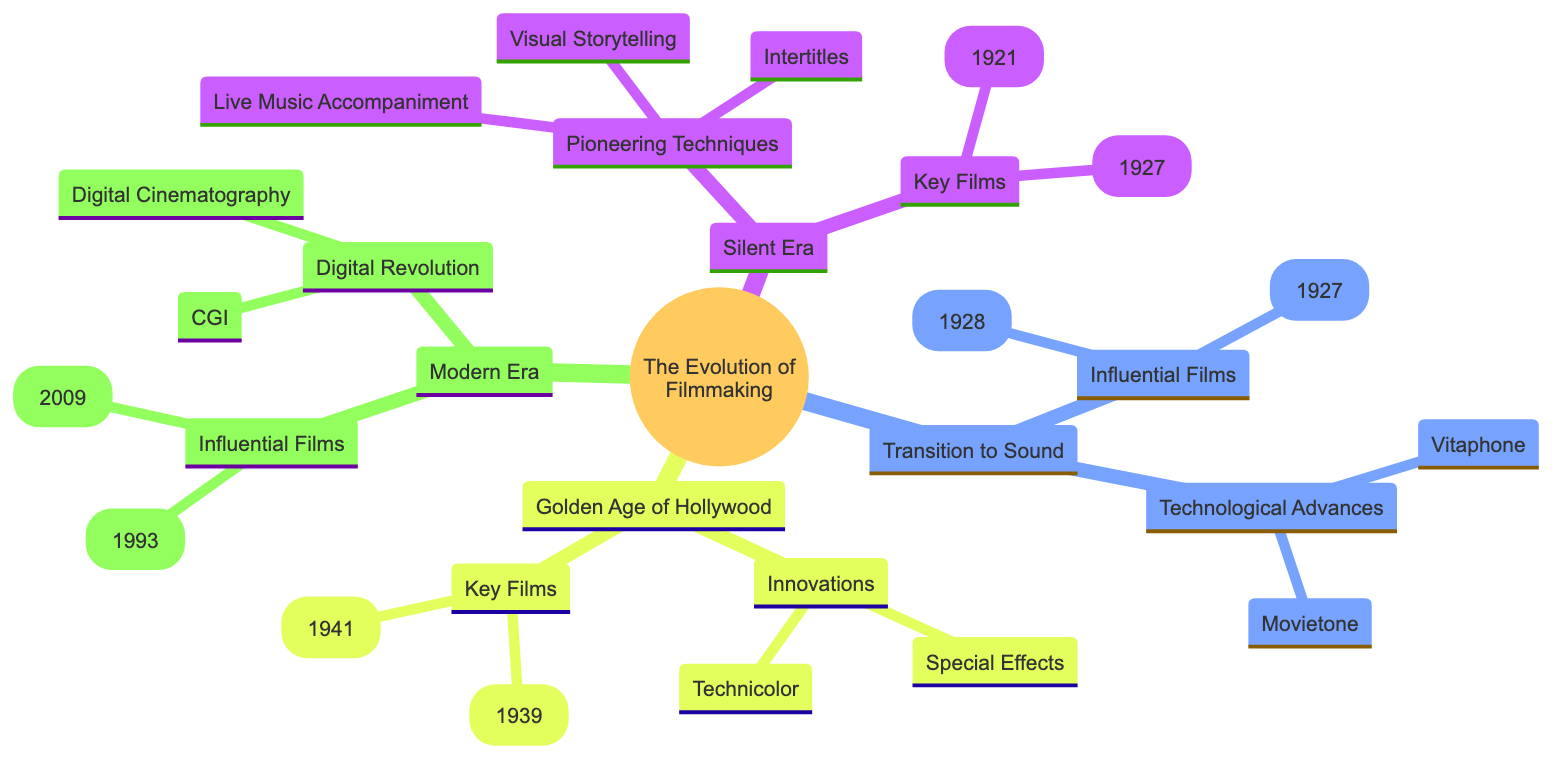What are two pioneering techniques from the Silent Era? According to the diagram, the "Pioneering Techniques" branch under "Silent Era" includes "Intertitles" and "Visual Storytelling". Thus, the two techniques are those listed in this section.
Answer: Intertitles, Visual Storytelling Who directed "Citizen Kane"? The diagram provides a section under "Key Films" in the "Golden Age of Hollywood" where "Citizen Kane" is listed along with its director, which is "Orson Welles".
Answer: Orson Welles What technological advance is associated with the Vitaphone? In the "Transition to Sound" section, it notes that "Vitaphone" is a "Sound-on-disc system", linking the technological advance directly with its description.
Answer: Sound-on-disc system How many key films are listed in the Golden Age of Hollywood? Under "Key Films" within the "Golden Age of Hollywood", there are two specific films listed, which refer to the count of films in that section. Therefore, the answer reflects this quantity.
Answer: 2 What film is recognized for pioneering CGI integration? The "Influential Films" under "Modern Era" states that "Jurassic Park (1993)" is significant for pioneering CGI integration, making it the key example of this evolution.
Answer: Jurassic Park (1993) Which sound system is tied to the concept of sound-on-film? The diagram specifies that "Movietone" falls under "Technological Advances" in the "Transition to Sound" category and is described as a "Sound-on-film system", indicating its association.
Answer: Sound-on-film system What was a distinctive feature of the special effects during the Golden Age of Hollywood? "Special Effects" under "Innovations" in the "Golden Age of Hollywood" is summarized by elements like "Miniatures, matte paintings", showing their distinctive techniques prevalent at the time.
Answer: Miniatures, matte paintings What year was "The Jazz Singer" released? The "Influential Films" section under "Transition to Sound" explicitly states "The Jazz Singer (1927)", indicating its release year and connecting it to the historical context.
Answer: 1927 